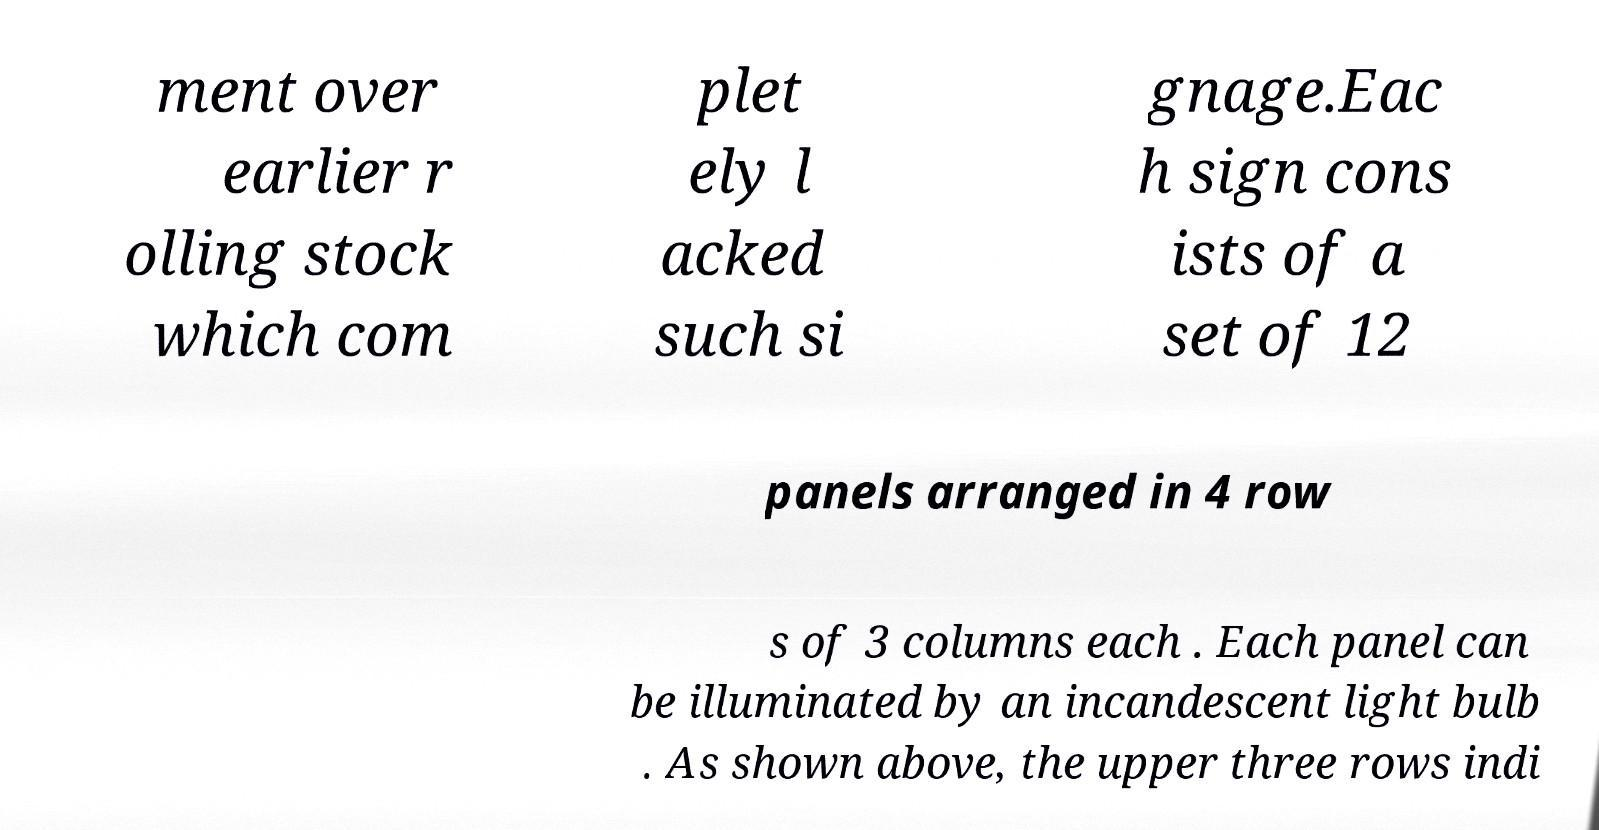I need the written content from this picture converted into text. Can you do that? Certainly! The picture displays a description of signage with the following content: '...ment over earlier rolling stock which completely lacked such signage. Each sign consists of a set of 12 panels arranged in 4 rows of 3 columns each. Each panel can be illuminated by an incandescent light bulb. As shown above, the upper three rows indicate...' Unfortunately, part of the text is missing, so this transcription is partial. 